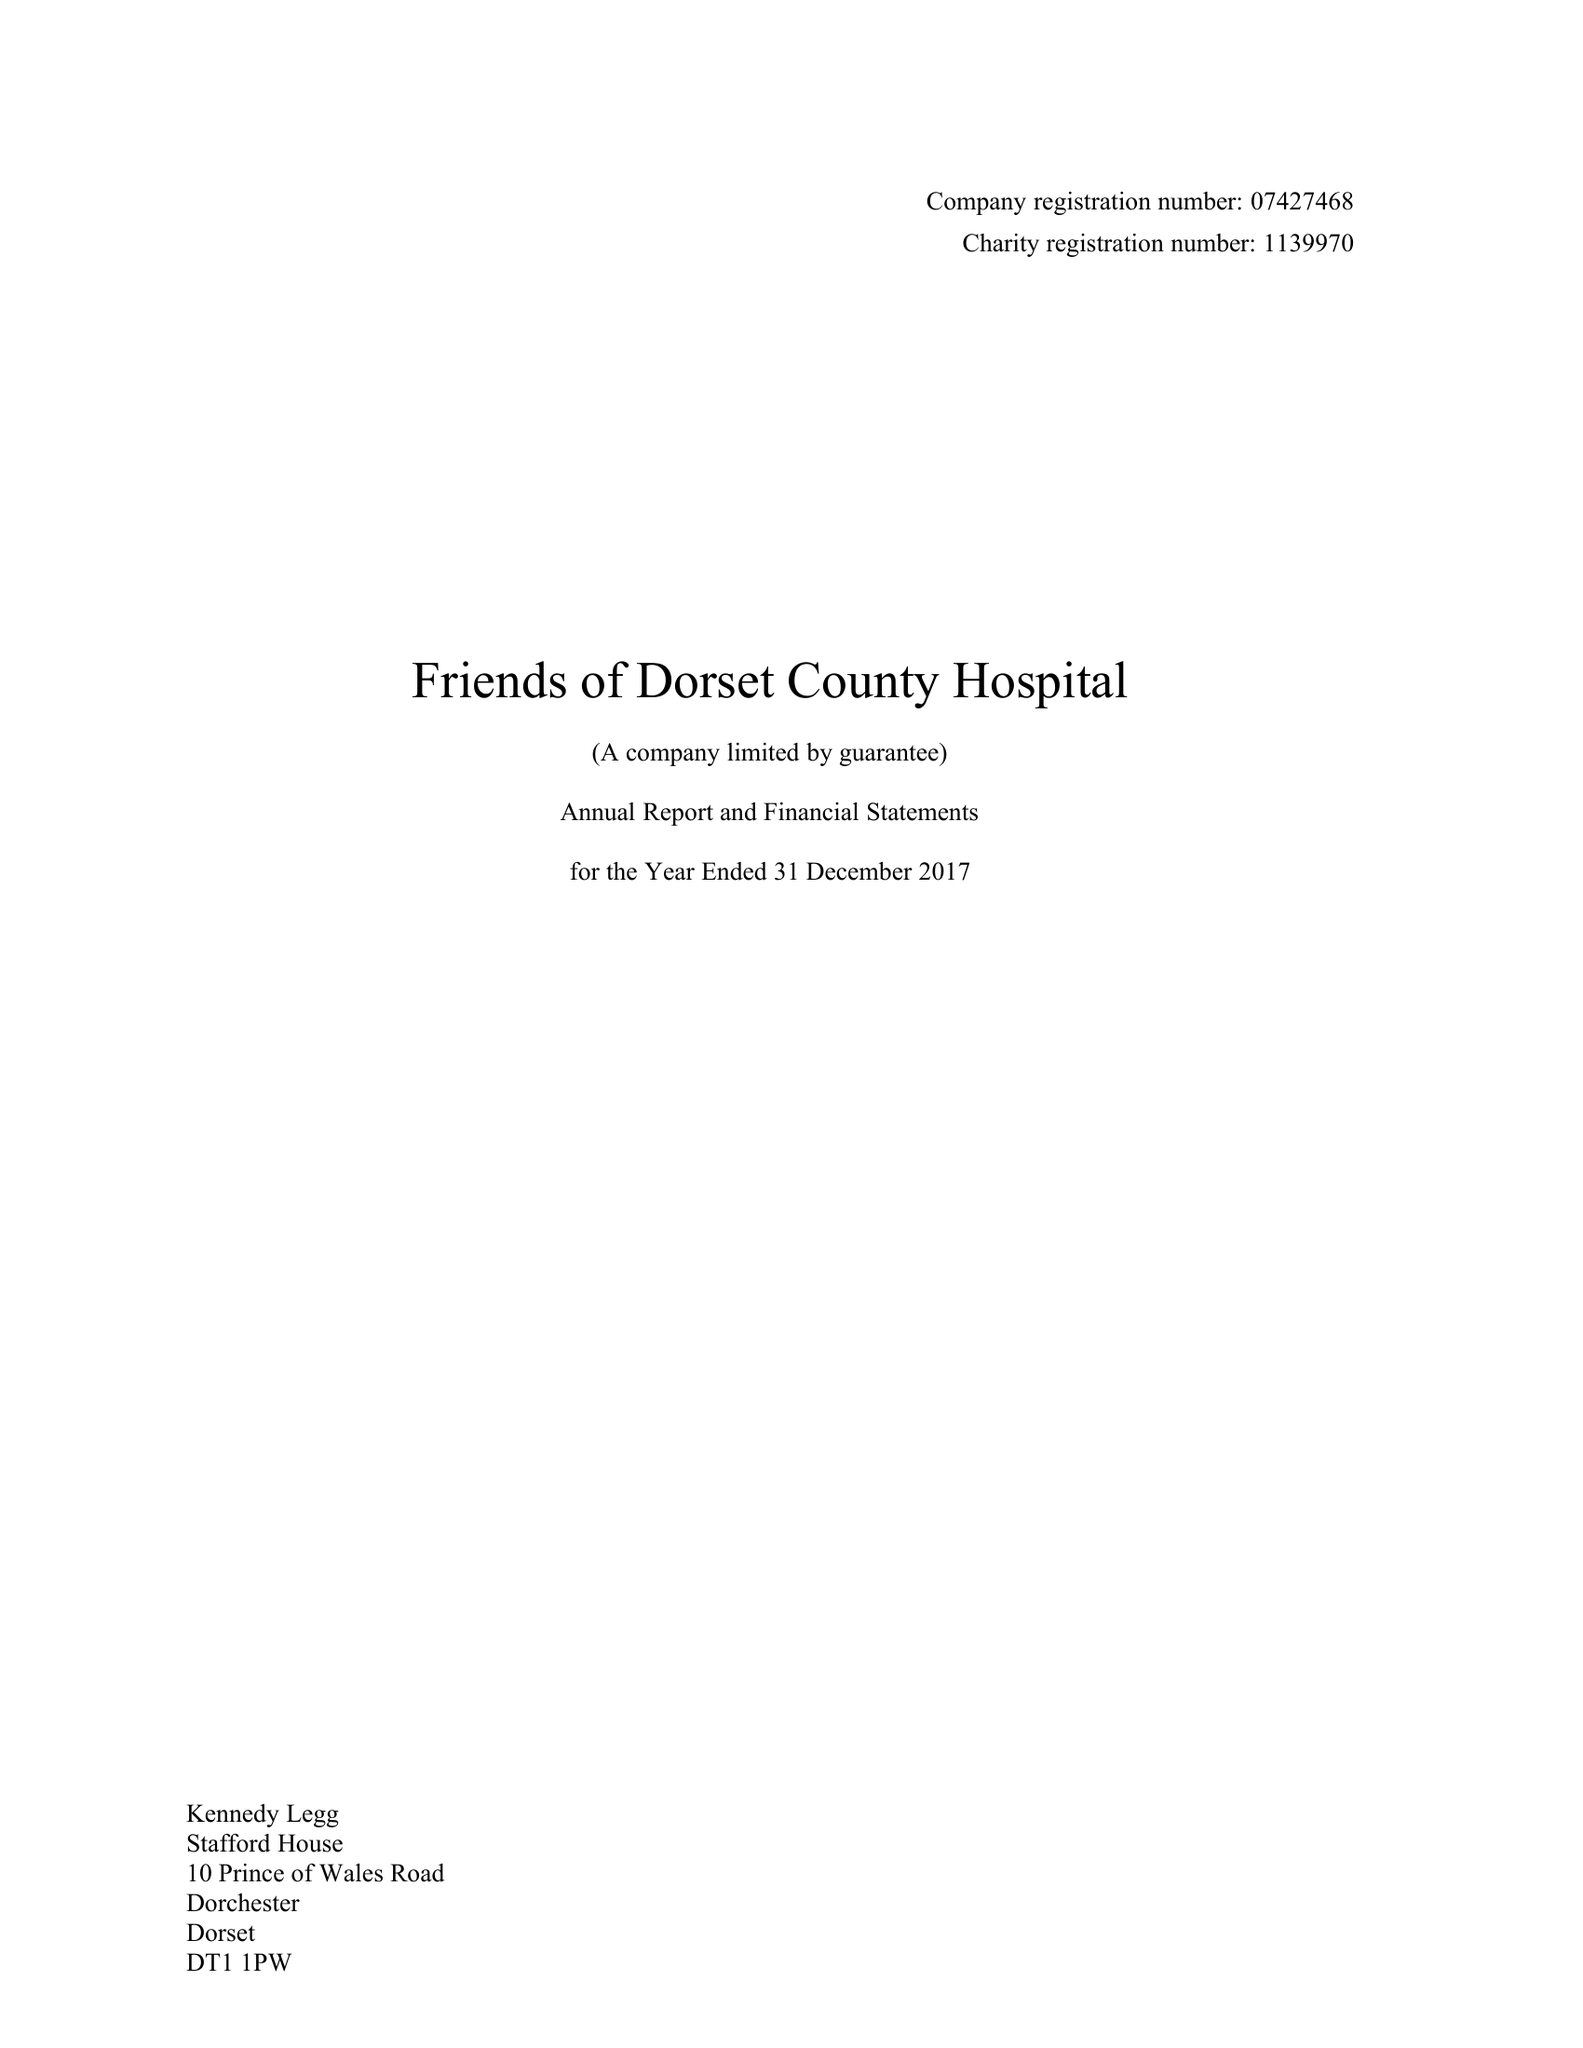What is the value for the address__street_line?
Answer the question using a single word or phrase. PRINCE OF WALES ROAD 